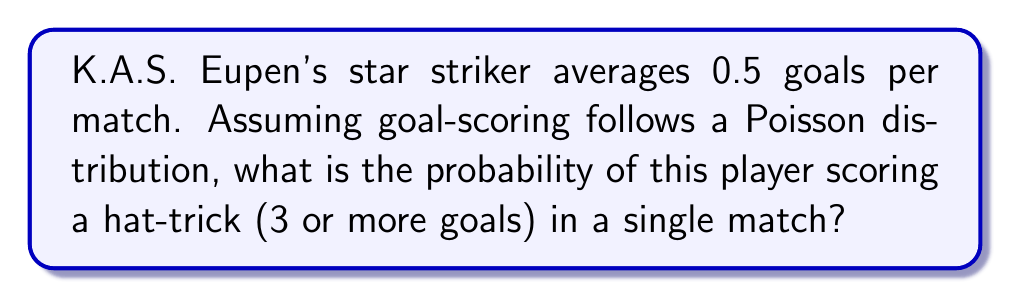What is the answer to this math problem? To solve this problem, we'll use the Poisson distribution, which is appropriate for modeling rare events like goal-scoring in football. Let's approach this step-by-step:

1) The Poisson distribution is given by the formula:

   $$P(X = k) = \frac{e^{-\lambda} \lambda^k}{k!}$$

   where $\lambda$ is the average rate of occurrences and $k$ is the number of occurrences.

2) In this case, $\lambda = 0.5$ (the average number of goals per match).

3) We need to find $P(X \geq 3)$, which is the probability of scoring 3 or more goals.

4) It's often easier to calculate this as $1 - P(X < 3)$, or $1 - [P(X = 0) + P(X = 1) + P(X = 2)]$.

5) Let's calculate each probability:

   $P(X = 0) = \frac{e^{-0.5} 0.5^0}{0!} = e^{-0.5} \approx 0.6065$

   $P(X = 1) = \frac{e^{-0.5} 0.5^1}{1!} = 0.5e^{-0.5} \approx 0.3033$

   $P(X = 2) = \frac{e^{-0.5} 0.5^2}{2!} = \frac{0.25e^{-0.5}}{2} \approx 0.0758$

6) Now, we can calculate the probability of scoring 3 or more goals:

   $P(X \geq 3) = 1 - [P(X = 0) + P(X = 1) + P(X = 2)]$
                $= 1 - (0.6065 + 0.3033 + 0.0758)$
                $= 1 - 0.9856$
                $= 0.0144$

Therefore, the probability of the striker scoring a hat-trick in a single match is approximately 0.0144 or 1.44%.
Answer: 0.0144 